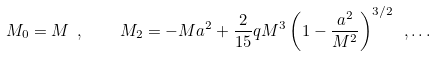Convert formula to latex. <formula><loc_0><loc_0><loc_500><loc_500>M _ { 0 } = M \ , \quad M _ { 2 } = - M a ^ { 2 } + \frac { 2 } { 1 5 } q M ^ { 3 } \left ( 1 - \frac { a ^ { 2 } } { M ^ { 2 } } \right ) ^ { 3 / 2 } \ , \dots</formula> 